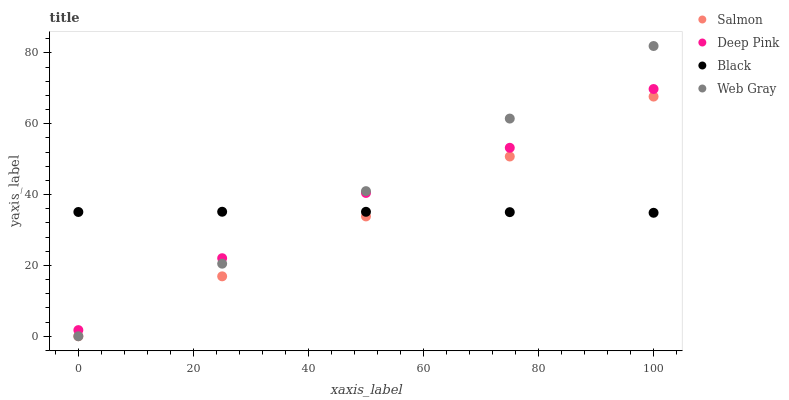Does Salmon have the minimum area under the curve?
Answer yes or no. Yes. Does Web Gray have the maximum area under the curve?
Answer yes or no. Yes. Does Black have the minimum area under the curve?
Answer yes or no. No. Does Black have the maximum area under the curve?
Answer yes or no. No. Is Web Gray the smoothest?
Answer yes or no. Yes. Is Deep Pink the roughest?
Answer yes or no. Yes. Is Black the smoothest?
Answer yes or no. No. Is Black the roughest?
Answer yes or no. No. Does Web Gray have the lowest value?
Answer yes or no. Yes. Does Deep Pink have the lowest value?
Answer yes or no. No. Does Web Gray have the highest value?
Answer yes or no. Yes. Does Deep Pink have the highest value?
Answer yes or no. No. Is Salmon less than Deep Pink?
Answer yes or no. Yes. Is Deep Pink greater than Salmon?
Answer yes or no. Yes. Does Web Gray intersect Deep Pink?
Answer yes or no. Yes. Is Web Gray less than Deep Pink?
Answer yes or no. No. Is Web Gray greater than Deep Pink?
Answer yes or no. No. Does Salmon intersect Deep Pink?
Answer yes or no. No. 